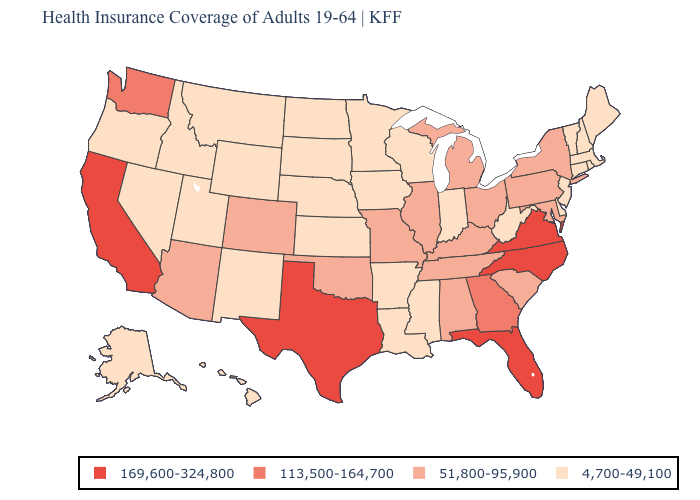What is the lowest value in the South?
Answer briefly. 4,700-49,100. What is the value of Nebraska?
Concise answer only. 4,700-49,100. Does the map have missing data?
Write a very short answer. No. Which states have the lowest value in the West?
Write a very short answer. Alaska, Hawaii, Idaho, Montana, Nevada, New Mexico, Oregon, Utah, Wyoming. Does Ohio have the lowest value in the USA?
Keep it brief. No. What is the value of Kansas?
Answer briefly. 4,700-49,100. Does Nebraska have a lower value than Maine?
Write a very short answer. No. Among the states that border Missouri , which have the lowest value?
Give a very brief answer. Arkansas, Iowa, Kansas, Nebraska. Among the states that border North Carolina , which have the highest value?
Be succinct. Virginia. Name the states that have a value in the range 51,800-95,900?
Be succinct. Alabama, Arizona, Colorado, Illinois, Kentucky, Maryland, Michigan, Missouri, New York, Ohio, Oklahoma, Pennsylvania, South Carolina, Tennessee. What is the highest value in states that border New York?
Answer briefly. 51,800-95,900. Does Texas have a higher value than Florida?
Give a very brief answer. No. What is the highest value in states that border Maryland?
Concise answer only. 169,600-324,800. Name the states that have a value in the range 113,500-164,700?
Write a very short answer. Georgia, Washington. What is the value of Nevada?
Answer briefly. 4,700-49,100. 